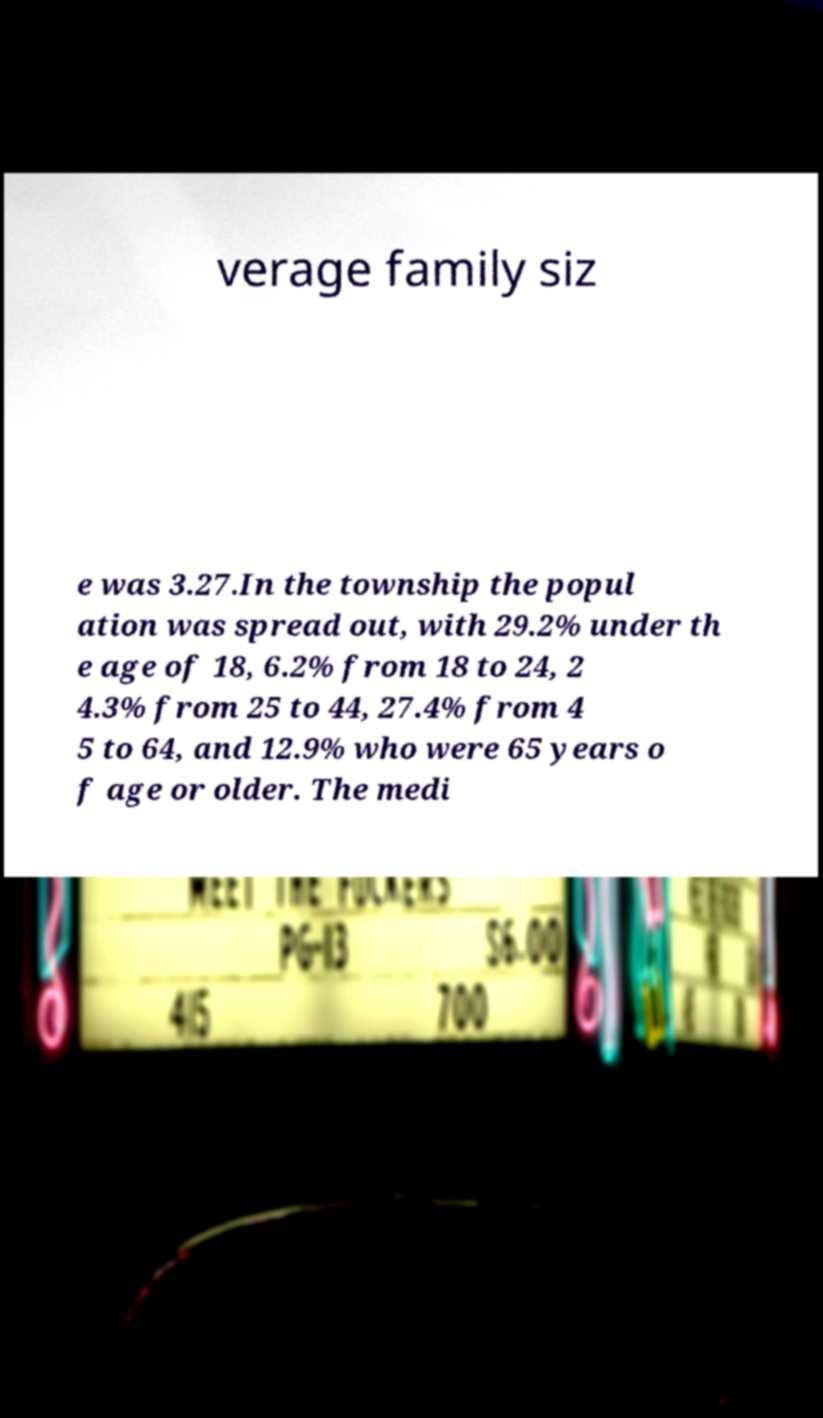Please identify and transcribe the text found in this image. verage family siz e was 3.27.In the township the popul ation was spread out, with 29.2% under th e age of 18, 6.2% from 18 to 24, 2 4.3% from 25 to 44, 27.4% from 4 5 to 64, and 12.9% who were 65 years o f age or older. The medi 